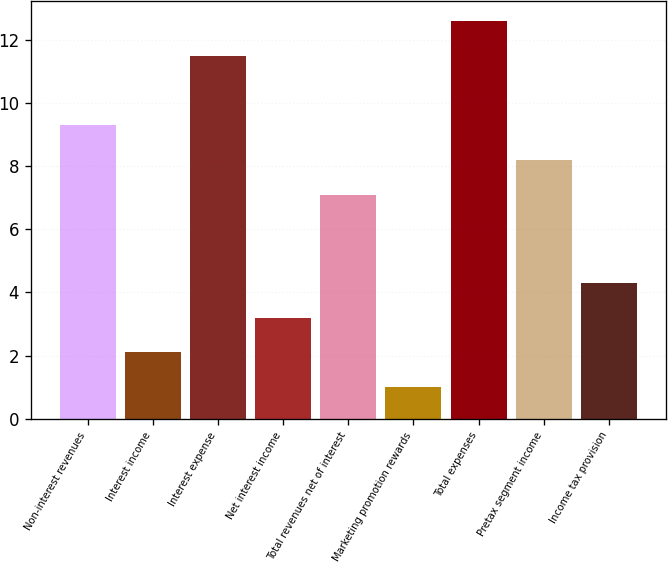Convert chart. <chart><loc_0><loc_0><loc_500><loc_500><bar_chart><fcel>Non-interest revenues<fcel>Interest income<fcel>Interest expense<fcel>Net interest income<fcel>Total revenues net of interest<fcel>Marketing promotion rewards<fcel>Total expenses<fcel>Pretax segment income<fcel>Income tax provision<nl><fcel>9.3<fcel>2.1<fcel>11.5<fcel>3.2<fcel>7.1<fcel>1<fcel>12.6<fcel>8.2<fcel>4.3<nl></chart> 